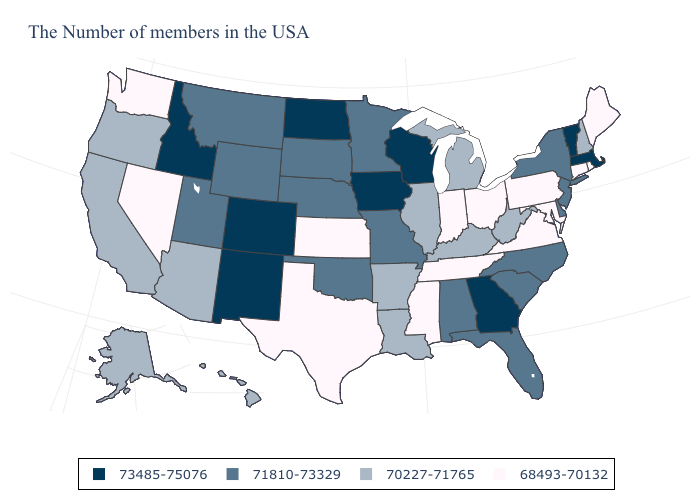Does the first symbol in the legend represent the smallest category?
Concise answer only. No. What is the value of Maine?
Be succinct. 68493-70132. Name the states that have a value in the range 68493-70132?
Answer briefly. Maine, Rhode Island, Connecticut, Maryland, Pennsylvania, Virginia, Ohio, Indiana, Tennessee, Mississippi, Kansas, Texas, Nevada, Washington. What is the lowest value in the USA?
Concise answer only. 68493-70132. Does North Carolina have the highest value in the South?
Keep it brief. No. Name the states that have a value in the range 73485-75076?
Keep it brief. Massachusetts, Vermont, Georgia, Wisconsin, Iowa, North Dakota, Colorado, New Mexico, Idaho. Does the first symbol in the legend represent the smallest category?
Be succinct. No. What is the value of Montana?
Concise answer only. 71810-73329. Does Wisconsin have the highest value in the USA?
Answer briefly. Yes. What is the highest value in the West ?
Quick response, please. 73485-75076. Among the states that border Massachusetts , which have the highest value?
Quick response, please. Vermont. Does Rhode Island have the highest value in the Northeast?
Concise answer only. No. What is the highest value in the USA?
Be succinct. 73485-75076. What is the lowest value in states that border New York?
Quick response, please. 68493-70132. Name the states that have a value in the range 68493-70132?
Short answer required. Maine, Rhode Island, Connecticut, Maryland, Pennsylvania, Virginia, Ohio, Indiana, Tennessee, Mississippi, Kansas, Texas, Nevada, Washington. 